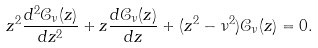Convert formula to latex. <formula><loc_0><loc_0><loc_500><loc_500>z ^ { 2 } \frac { d ^ { 2 } \mathcal { C } _ { \nu } ( z ) } { d z ^ { 2 } } + z \frac { d \mathcal { C } _ { \nu } ( z ) } { d z } + ( z ^ { 2 } - \nu ^ { 2 } ) \mathcal { C _ { \nu } } ( z ) = 0 .</formula> 